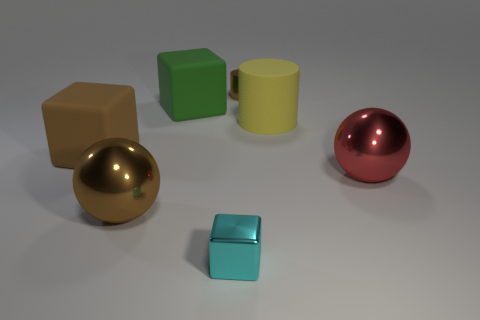Subtract all large matte blocks. How many blocks are left? 1 Subtract all balls. How many objects are left? 5 Add 2 small brown cylinders. How many objects exist? 9 Add 6 small things. How many small things exist? 8 Subtract all red balls. How many balls are left? 1 Subtract 0 blue cylinders. How many objects are left? 7 Subtract 2 balls. How many balls are left? 0 Subtract all cyan cubes. Subtract all red spheres. How many cubes are left? 2 Subtract all gray cubes. How many brown spheres are left? 1 Subtract all big metal things. Subtract all small cyan metallic blocks. How many objects are left? 4 